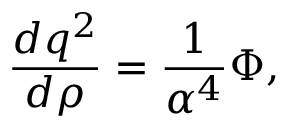<formula> <loc_0><loc_0><loc_500><loc_500>{ \frac { d q ^ { 2 } } { d \rho } } = { \frac { 1 } { \alpha ^ { 4 } } } \Phi ,</formula> 